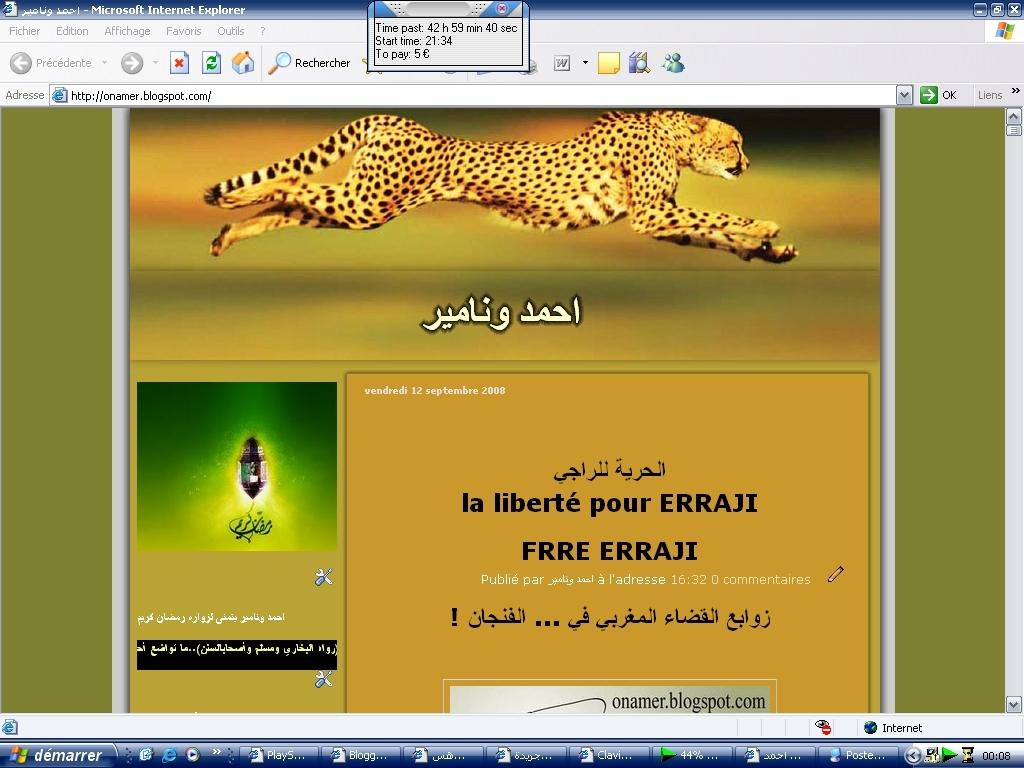What type of device is shown in the image? The image is a screenshot of a computer. What can be seen in the screenshot? There is a picture of a cheetah and text visible in the screenshot. What type of garden can be seen in the background of the cheetah's habitat in the image? There is no garden visible in the image, as it only shows a picture of a cheetah and text on a computer screenshot. 